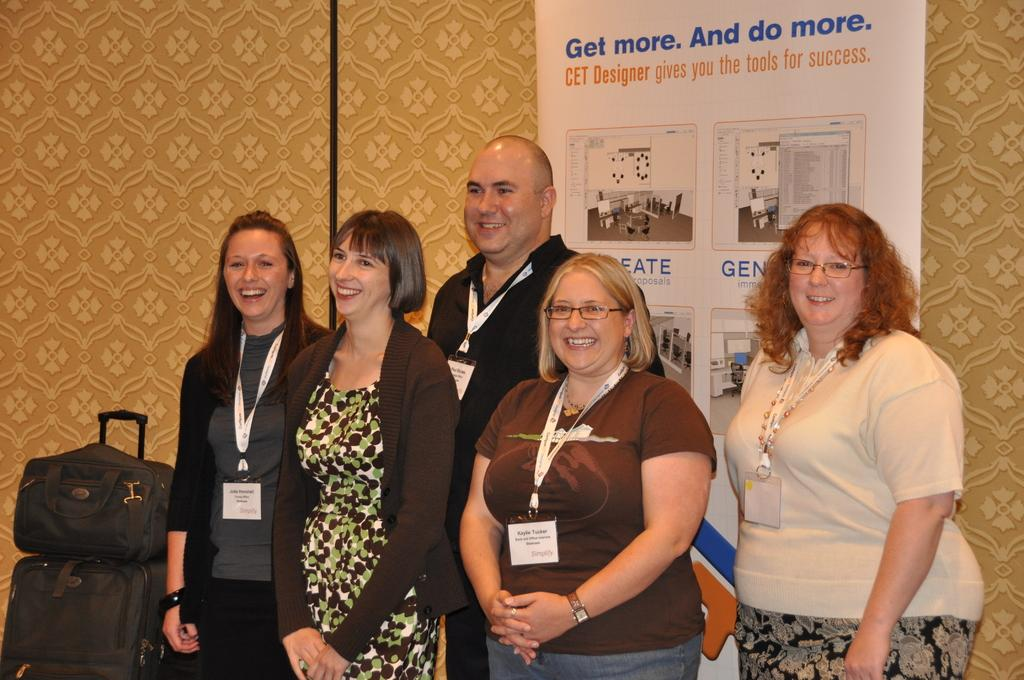How many people are present in the image? There are five persons standing in the image. Can you describe the expression of one of the persons? A woman is smiling in the image. What can be seen on the floor in the image? There are bags on the floor in the image. What color is the badge worn by the person in the image? There is no badge present in the image. What emotion might the person feel if they were experiencing shame? The image does not depict any emotions related to shame, as the woman is smiling. 